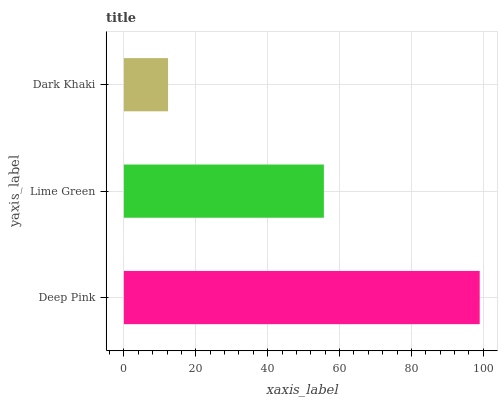Is Dark Khaki the minimum?
Answer yes or no. Yes. Is Deep Pink the maximum?
Answer yes or no. Yes. Is Lime Green the minimum?
Answer yes or no. No. Is Lime Green the maximum?
Answer yes or no. No. Is Deep Pink greater than Lime Green?
Answer yes or no. Yes. Is Lime Green less than Deep Pink?
Answer yes or no. Yes. Is Lime Green greater than Deep Pink?
Answer yes or no. No. Is Deep Pink less than Lime Green?
Answer yes or no. No. Is Lime Green the high median?
Answer yes or no. Yes. Is Lime Green the low median?
Answer yes or no. Yes. Is Deep Pink the high median?
Answer yes or no. No. Is Dark Khaki the low median?
Answer yes or no. No. 